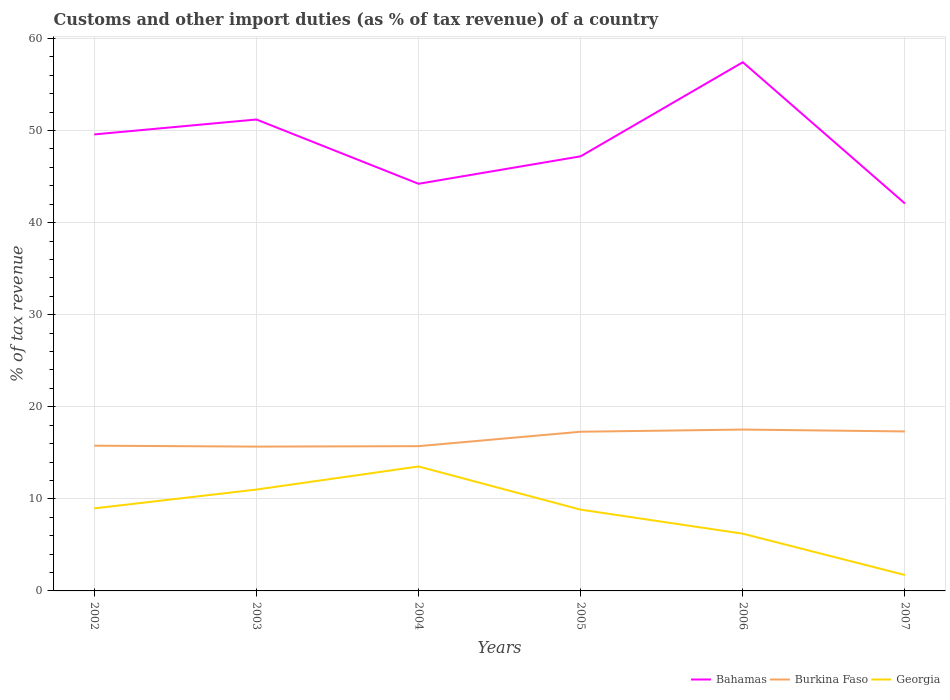How many different coloured lines are there?
Make the answer very short. 3. Is the number of lines equal to the number of legend labels?
Your answer should be very brief. Yes. Across all years, what is the maximum percentage of tax revenue from customs in Georgia?
Your answer should be compact. 1.73. In which year was the percentage of tax revenue from customs in Burkina Faso maximum?
Your answer should be very brief. 2003. What is the total percentage of tax revenue from customs in Burkina Faso in the graph?
Ensure brevity in your answer.  -1.61. What is the difference between the highest and the second highest percentage of tax revenue from customs in Bahamas?
Your answer should be very brief. 15.35. How many years are there in the graph?
Provide a short and direct response. 6. Does the graph contain grids?
Offer a terse response. Yes. How are the legend labels stacked?
Provide a succinct answer. Horizontal. What is the title of the graph?
Ensure brevity in your answer.  Customs and other import duties (as % of tax revenue) of a country. What is the label or title of the Y-axis?
Provide a succinct answer. % of tax revenue. What is the % of tax revenue of Bahamas in 2002?
Ensure brevity in your answer.  49.57. What is the % of tax revenue of Burkina Faso in 2002?
Ensure brevity in your answer.  15.77. What is the % of tax revenue of Georgia in 2002?
Make the answer very short. 8.96. What is the % of tax revenue of Bahamas in 2003?
Your answer should be very brief. 51.2. What is the % of tax revenue of Burkina Faso in 2003?
Keep it short and to the point. 15.67. What is the % of tax revenue of Georgia in 2003?
Provide a short and direct response. 11.01. What is the % of tax revenue in Bahamas in 2004?
Offer a very short reply. 44.21. What is the % of tax revenue in Burkina Faso in 2004?
Offer a terse response. 15.72. What is the % of tax revenue in Georgia in 2004?
Provide a short and direct response. 13.51. What is the % of tax revenue in Bahamas in 2005?
Offer a terse response. 47.2. What is the % of tax revenue of Burkina Faso in 2005?
Keep it short and to the point. 17.29. What is the % of tax revenue in Georgia in 2005?
Your answer should be very brief. 8.83. What is the % of tax revenue of Bahamas in 2006?
Give a very brief answer. 57.42. What is the % of tax revenue of Burkina Faso in 2006?
Your response must be concise. 17.52. What is the % of tax revenue of Georgia in 2006?
Offer a very short reply. 6.22. What is the % of tax revenue of Bahamas in 2007?
Give a very brief answer. 42.07. What is the % of tax revenue of Burkina Faso in 2007?
Offer a terse response. 17.32. What is the % of tax revenue in Georgia in 2007?
Provide a short and direct response. 1.73. Across all years, what is the maximum % of tax revenue of Bahamas?
Ensure brevity in your answer.  57.42. Across all years, what is the maximum % of tax revenue in Burkina Faso?
Provide a short and direct response. 17.52. Across all years, what is the maximum % of tax revenue of Georgia?
Keep it short and to the point. 13.51. Across all years, what is the minimum % of tax revenue of Bahamas?
Your answer should be compact. 42.07. Across all years, what is the minimum % of tax revenue of Burkina Faso?
Your response must be concise. 15.67. Across all years, what is the minimum % of tax revenue of Georgia?
Give a very brief answer. 1.73. What is the total % of tax revenue in Bahamas in the graph?
Offer a terse response. 291.67. What is the total % of tax revenue of Burkina Faso in the graph?
Provide a short and direct response. 99.3. What is the total % of tax revenue of Georgia in the graph?
Provide a succinct answer. 50.25. What is the difference between the % of tax revenue of Bahamas in 2002 and that in 2003?
Your response must be concise. -1.62. What is the difference between the % of tax revenue of Burkina Faso in 2002 and that in 2003?
Make the answer very short. 0.1. What is the difference between the % of tax revenue of Georgia in 2002 and that in 2003?
Make the answer very short. -2.04. What is the difference between the % of tax revenue in Bahamas in 2002 and that in 2004?
Ensure brevity in your answer.  5.36. What is the difference between the % of tax revenue of Burkina Faso in 2002 and that in 2004?
Provide a succinct answer. 0.05. What is the difference between the % of tax revenue of Georgia in 2002 and that in 2004?
Make the answer very short. -4.55. What is the difference between the % of tax revenue in Bahamas in 2002 and that in 2005?
Your answer should be compact. 2.38. What is the difference between the % of tax revenue of Burkina Faso in 2002 and that in 2005?
Give a very brief answer. -1.51. What is the difference between the % of tax revenue in Georgia in 2002 and that in 2005?
Provide a short and direct response. 0.14. What is the difference between the % of tax revenue in Bahamas in 2002 and that in 2006?
Offer a very short reply. -7.84. What is the difference between the % of tax revenue in Burkina Faso in 2002 and that in 2006?
Keep it short and to the point. -1.75. What is the difference between the % of tax revenue of Georgia in 2002 and that in 2006?
Your answer should be compact. 2.75. What is the difference between the % of tax revenue in Bahamas in 2002 and that in 2007?
Your answer should be very brief. 7.5. What is the difference between the % of tax revenue in Burkina Faso in 2002 and that in 2007?
Make the answer very short. -1.55. What is the difference between the % of tax revenue in Georgia in 2002 and that in 2007?
Make the answer very short. 7.24. What is the difference between the % of tax revenue of Bahamas in 2003 and that in 2004?
Offer a very short reply. 6.98. What is the difference between the % of tax revenue of Burkina Faso in 2003 and that in 2004?
Provide a short and direct response. -0.05. What is the difference between the % of tax revenue of Georgia in 2003 and that in 2004?
Provide a short and direct response. -2.51. What is the difference between the % of tax revenue in Bahamas in 2003 and that in 2005?
Your answer should be very brief. 4. What is the difference between the % of tax revenue in Burkina Faso in 2003 and that in 2005?
Your answer should be compact. -1.61. What is the difference between the % of tax revenue in Georgia in 2003 and that in 2005?
Offer a very short reply. 2.18. What is the difference between the % of tax revenue of Bahamas in 2003 and that in 2006?
Provide a succinct answer. -6.22. What is the difference between the % of tax revenue of Burkina Faso in 2003 and that in 2006?
Your response must be concise. -1.85. What is the difference between the % of tax revenue of Georgia in 2003 and that in 2006?
Provide a short and direct response. 4.79. What is the difference between the % of tax revenue in Bahamas in 2003 and that in 2007?
Offer a very short reply. 9.13. What is the difference between the % of tax revenue in Burkina Faso in 2003 and that in 2007?
Your response must be concise. -1.65. What is the difference between the % of tax revenue of Georgia in 2003 and that in 2007?
Your answer should be very brief. 9.28. What is the difference between the % of tax revenue of Bahamas in 2004 and that in 2005?
Give a very brief answer. -2.98. What is the difference between the % of tax revenue in Burkina Faso in 2004 and that in 2005?
Your answer should be compact. -1.57. What is the difference between the % of tax revenue in Georgia in 2004 and that in 2005?
Give a very brief answer. 4.69. What is the difference between the % of tax revenue of Bahamas in 2004 and that in 2006?
Provide a succinct answer. -13.2. What is the difference between the % of tax revenue in Burkina Faso in 2004 and that in 2006?
Your answer should be compact. -1.8. What is the difference between the % of tax revenue of Georgia in 2004 and that in 2006?
Your answer should be compact. 7.3. What is the difference between the % of tax revenue in Bahamas in 2004 and that in 2007?
Offer a very short reply. 2.14. What is the difference between the % of tax revenue of Burkina Faso in 2004 and that in 2007?
Your answer should be compact. -1.6. What is the difference between the % of tax revenue in Georgia in 2004 and that in 2007?
Ensure brevity in your answer.  11.79. What is the difference between the % of tax revenue of Bahamas in 2005 and that in 2006?
Keep it short and to the point. -10.22. What is the difference between the % of tax revenue of Burkina Faso in 2005 and that in 2006?
Give a very brief answer. -0.24. What is the difference between the % of tax revenue of Georgia in 2005 and that in 2006?
Offer a terse response. 2.61. What is the difference between the % of tax revenue in Bahamas in 2005 and that in 2007?
Provide a short and direct response. 5.13. What is the difference between the % of tax revenue of Burkina Faso in 2005 and that in 2007?
Your answer should be very brief. -0.03. What is the difference between the % of tax revenue in Georgia in 2005 and that in 2007?
Give a very brief answer. 7.1. What is the difference between the % of tax revenue in Bahamas in 2006 and that in 2007?
Your answer should be very brief. 15.35. What is the difference between the % of tax revenue in Burkina Faso in 2006 and that in 2007?
Offer a very short reply. 0.2. What is the difference between the % of tax revenue in Georgia in 2006 and that in 2007?
Your answer should be very brief. 4.49. What is the difference between the % of tax revenue of Bahamas in 2002 and the % of tax revenue of Burkina Faso in 2003?
Offer a very short reply. 33.9. What is the difference between the % of tax revenue of Bahamas in 2002 and the % of tax revenue of Georgia in 2003?
Your answer should be compact. 38.57. What is the difference between the % of tax revenue of Burkina Faso in 2002 and the % of tax revenue of Georgia in 2003?
Give a very brief answer. 4.76. What is the difference between the % of tax revenue of Bahamas in 2002 and the % of tax revenue of Burkina Faso in 2004?
Your answer should be compact. 33.85. What is the difference between the % of tax revenue in Bahamas in 2002 and the % of tax revenue in Georgia in 2004?
Offer a very short reply. 36.06. What is the difference between the % of tax revenue in Burkina Faso in 2002 and the % of tax revenue in Georgia in 2004?
Your answer should be compact. 2.26. What is the difference between the % of tax revenue in Bahamas in 2002 and the % of tax revenue in Burkina Faso in 2005?
Your answer should be compact. 32.29. What is the difference between the % of tax revenue of Bahamas in 2002 and the % of tax revenue of Georgia in 2005?
Make the answer very short. 40.75. What is the difference between the % of tax revenue in Burkina Faso in 2002 and the % of tax revenue in Georgia in 2005?
Provide a succinct answer. 6.95. What is the difference between the % of tax revenue of Bahamas in 2002 and the % of tax revenue of Burkina Faso in 2006?
Give a very brief answer. 32.05. What is the difference between the % of tax revenue of Bahamas in 2002 and the % of tax revenue of Georgia in 2006?
Provide a short and direct response. 43.36. What is the difference between the % of tax revenue of Burkina Faso in 2002 and the % of tax revenue of Georgia in 2006?
Offer a terse response. 9.56. What is the difference between the % of tax revenue of Bahamas in 2002 and the % of tax revenue of Burkina Faso in 2007?
Provide a short and direct response. 32.25. What is the difference between the % of tax revenue of Bahamas in 2002 and the % of tax revenue of Georgia in 2007?
Offer a very short reply. 47.85. What is the difference between the % of tax revenue of Burkina Faso in 2002 and the % of tax revenue of Georgia in 2007?
Keep it short and to the point. 14.04. What is the difference between the % of tax revenue in Bahamas in 2003 and the % of tax revenue in Burkina Faso in 2004?
Offer a very short reply. 35.47. What is the difference between the % of tax revenue in Bahamas in 2003 and the % of tax revenue in Georgia in 2004?
Provide a succinct answer. 37.68. What is the difference between the % of tax revenue in Burkina Faso in 2003 and the % of tax revenue in Georgia in 2004?
Keep it short and to the point. 2.16. What is the difference between the % of tax revenue in Bahamas in 2003 and the % of tax revenue in Burkina Faso in 2005?
Make the answer very short. 33.91. What is the difference between the % of tax revenue in Bahamas in 2003 and the % of tax revenue in Georgia in 2005?
Your response must be concise. 42.37. What is the difference between the % of tax revenue in Burkina Faso in 2003 and the % of tax revenue in Georgia in 2005?
Your answer should be very brief. 6.85. What is the difference between the % of tax revenue of Bahamas in 2003 and the % of tax revenue of Burkina Faso in 2006?
Keep it short and to the point. 33.67. What is the difference between the % of tax revenue of Bahamas in 2003 and the % of tax revenue of Georgia in 2006?
Keep it short and to the point. 44.98. What is the difference between the % of tax revenue in Burkina Faso in 2003 and the % of tax revenue in Georgia in 2006?
Give a very brief answer. 9.46. What is the difference between the % of tax revenue of Bahamas in 2003 and the % of tax revenue of Burkina Faso in 2007?
Make the answer very short. 33.88. What is the difference between the % of tax revenue in Bahamas in 2003 and the % of tax revenue in Georgia in 2007?
Give a very brief answer. 49.47. What is the difference between the % of tax revenue in Burkina Faso in 2003 and the % of tax revenue in Georgia in 2007?
Make the answer very short. 13.95. What is the difference between the % of tax revenue of Bahamas in 2004 and the % of tax revenue of Burkina Faso in 2005?
Keep it short and to the point. 26.93. What is the difference between the % of tax revenue in Bahamas in 2004 and the % of tax revenue in Georgia in 2005?
Ensure brevity in your answer.  35.39. What is the difference between the % of tax revenue of Burkina Faso in 2004 and the % of tax revenue of Georgia in 2005?
Provide a succinct answer. 6.9. What is the difference between the % of tax revenue in Bahamas in 2004 and the % of tax revenue in Burkina Faso in 2006?
Ensure brevity in your answer.  26.69. What is the difference between the % of tax revenue in Bahamas in 2004 and the % of tax revenue in Georgia in 2006?
Keep it short and to the point. 38. What is the difference between the % of tax revenue of Burkina Faso in 2004 and the % of tax revenue of Georgia in 2006?
Offer a terse response. 9.51. What is the difference between the % of tax revenue in Bahamas in 2004 and the % of tax revenue in Burkina Faso in 2007?
Ensure brevity in your answer.  26.89. What is the difference between the % of tax revenue in Bahamas in 2004 and the % of tax revenue in Georgia in 2007?
Your response must be concise. 42.49. What is the difference between the % of tax revenue of Burkina Faso in 2004 and the % of tax revenue of Georgia in 2007?
Provide a short and direct response. 13.99. What is the difference between the % of tax revenue of Bahamas in 2005 and the % of tax revenue of Burkina Faso in 2006?
Provide a succinct answer. 29.67. What is the difference between the % of tax revenue of Bahamas in 2005 and the % of tax revenue of Georgia in 2006?
Offer a very short reply. 40.98. What is the difference between the % of tax revenue of Burkina Faso in 2005 and the % of tax revenue of Georgia in 2006?
Make the answer very short. 11.07. What is the difference between the % of tax revenue of Bahamas in 2005 and the % of tax revenue of Burkina Faso in 2007?
Your response must be concise. 29.88. What is the difference between the % of tax revenue of Bahamas in 2005 and the % of tax revenue of Georgia in 2007?
Keep it short and to the point. 45.47. What is the difference between the % of tax revenue of Burkina Faso in 2005 and the % of tax revenue of Georgia in 2007?
Give a very brief answer. 15.56. What is the difference between the % of tax revenue in Bahamas in 2006 and the % of tax revenue in Burkina Faso in 2007?
Provide a short and direct response. 40.1. What is the difference between the % of tax revenue in Bahamas in 2006 and the % of tax revenue in Georgia in 2007?
Your response must be concise. 55.69. What is the difference between the % of tax revenue in Burkina Faso in 2006 and the % of tax revenue in Georgia in 2007?
Your response must be concise. 15.8. What is the average % of tax revenue of Bahamas per year?
Your answer should be compact. 48.61. What is the average % of tax revenue of Burkina Faso per year?
Your response must be concise. 16.55. What is the average % of tax revenue of Georgia per year?
Ensure brevity in your answer.  8.38. In the year 2002, what is the difference between the % of tax revenue in Bahamas and % of tax revenue in Burkina Faso?
Provide a succinct answer. 33.8. In the year 2002, what is the difference between the % of tax revenue of Bahamas and % of tax revenue of Georgia?
Provide a short and direct response. 40.61. In the year 2002, what is the difference between the % of tax revenue in Burkina Faso and % of tax revenue in Georgia?
Your answer should be compact. 6.81. In the year 2003, what is the difference between the % of tax revenue of Bahamas and % of tax revenue of Burkina Faso?
Ensure brevity in your answer.  35.52. In the year 2003, what is the difference between the % of tax revenue of Bahamas and % of tax revenue of Georgia?
Offer a very short reply. 40.19. In the year 2003, what is the difference between the % of tax revenue in Burkina Faso and % of tax revenue in Georgia?
Your answer should be very brief. 4.66. In the year 2004, what is the difference between the % of tax revenue in Bahamas and % of tax revenue in Burkina Faso?
Give a very brief answer. 28.49. In the year 2004, what is the difference between the % of tax revenue in Bahamas and % of tax revenue in Georgia?
Give a very brief answer. 30.7. In the year 2004, what is the difference between the % of tax revenue of Burkina Faso and % of tax revenue of Georgia?
Your answer should be very brief. 2.21. In the year 2005, what is the difference between the % of tax revenue in Bahamas and % of tax revenue in Burkina Faso?
Provide a succinct answer. 29.91. In the year 2005, what is the difference between the % of tax revenue of Bahamas and % of tax revenue of Georgia?
Offer a very short reply. 38.37. In the year 2005, what is the difference between the % of tax revenue of Burkina Faso and % of tax revenue of Georgia?
Offer a terse response. 8.46. In the year 2006, what is the difference between the % of tax revenue in Bahamas and % of tax revenue in Burkina Faso?
Provide a short and direct response. 39.89. In the year 2006, what is the difference between the % of tax revenue of Bahamas and % of tax revenue of Georgia?
Your response must be concise. 51.2. In the year 2006, what is the difference between the % of tax revenue of Burkina Faso and % of tax revenue of Georgia?
Make the answer very short. 11.31. In the year 2007, what is the difference between the % of tax revenue of Bahamas and % of tax revenue of Burkina Faso?
Your answer should be compact. 24.75. In the year 2007, what is the difference between the % of tax revenue in Bahamas and % of tax revenue in Georgia?
Keep it short and to the point. 40.34. In the year 2007, what is the difference between the % of tax revenue of Burkina Faso and % of tax revenue of Georgia?
Make the answer very short. 15.59. What is the ratio of the % of tax revenue in Bahamas in 2002 to that in 2003?
Your response must be concise. 0.97. What is the ratio of the % of tax revenue of Georgia in 2002 to that in 2003?
Make the answer very short. 0.81. What is the ratio of the % of tax revenue of Bahamas in 2002 to that in 2004?
Offer a very short reply. 1.12. What is the ratio of the % of tax revenue of Georgia in 2002 to that in 2004?
Offer a terse response. 0.66. What is the ratio of the % of tax revenue of Bahamas in 2002 to that in 2005?
Provide a succinct answer. 1.05. What is the ratio of the % of tax revenue of Burkina Faso in 2002 to that in 2005?
Your answer should be very brief. 0.91. What is the ratio of the % of tax revenue in Georgia in 2002 to that in 2005?
Make the answer very short. 1.02. What is the ratio of the % of tax revenue in Bahamas in 2002 to that in 2006?
Make the answer very short. 0.86. What is the ratio of the % of tax revenue of Burkina Faso in 2002 to that in 2006?
Your answer should be compact. 0.9. What is the ratio of the % of tax revenue in Georgia in 2002 to that in 2006?
Your answer should be compact. 1.44. What is the ratio of the % of tax revenue of Bahamas in 2002 to that in 2007?
Offer a terse response. 1.18. What is the ratio of the % of tax revenue in Burkina Faso in 2002 to that in 2007?
Offer a very short reply. 0.91. What is the ratio of the % of tax revenue in Georgia in 2002 to that in 2007?
Your answer should be very brief. 5.19. What is the ratio of the % of tax revenue in Bahamas in 2003 to that in 2004?
Give a very brief answer. 1.16. What is the ratio of the % of tax revenue in Burkina Faso in 2003 to that in 2004?
Provide a short and direct response. 1. What is the ratio of the % of tax revenue in Georgia in 2003 to that in 2004?
Your response must be concise. 0.81. What is the ratio of the % of tax revenue in Bahamas in 2003 to that in 2005?
Offer a terse response. 1.08. What is the ratio of the % of tax revenue in Burkina Faso in 2003 to that in 2005?
Offer a terse response. 0.91. What is the ratio of the % of tax revenue of Georgia in 2003 to that in 2005?
Offer a terse response. 1.25. What is the ratio of the % of tax revenue in Bahamas in 2003 to that in 2006?
Give a very brief answer. 0.89. What is the ratio of the % of tax revenue of Burkina Faso in 2003 to that in 2006?
Provide a succinct answer. 0.89. What is the ratio of the % of tax revenue of Georgia in 2003 to that in 2006?
Your answer should be compact. 1.77. What is the ratio of the % of tax revenue of Bahamas in 2003 to that in 2007?
Your answer should be compact. 1.22. What is the ratio of the % of tax revenue in Burkina Faso in 2003 to that in 2007?
Provide a short and direct response. 0.9. What is the ratio of the % of tax revenue in Georgia in 2003 to that in 2007?
Keep it short and to the point. 6.37. What is the ratio of the % of tax revenue in Bahamas in 2004 to that in 2005?
Keep it short and to the point. 0.94. What is the ratio of the % of tax revenue of Burkina Faso in 2004 to that in 2005?
Keep it short and to the point. 0.91. What is the ratio of the % of tax revenue of Georgia in 2004 to that in 2005?
Provide a succinct answer. 1.53. What is the ratio of the % of tax revenue of Bahamas in 2004 to that in 2006?
Ensure brevity in your answer.  0.77. What is the ratio of the % of tax revenue of Burkina Faso in 2004 to that in 2006?
Ensure brevity in your answer.  0.9. What is the ratio of the % of tax revenue in Georgia in 2004 to that in 2006?
Provide a succinct answer. 2.17. What is the ratio of the % of tax revenue of Bahamas in 2004 to that in 2007?
Provide a short and direct response. 1.05. What is the ratio of the % of tax revenue in Burkina Faso in 2004 to that in 2007?
Provide a short and direct response. 0.91. What is the ratio of the % of tax revenue of Georgia in 2004 to that in 2007?
Keep it short and to the point. 7.82. What is the ratio of the % of tax revenue of Bahamas in 2005 to that in 2006?
Offer a very short reply. 0.82. What is the ratio of the % of tax revenue of Burkina Faso in 2005 to that in 2006?
Your response must be concise. 0.99. What is the ratio of the % of tax revenue in Georgia in 2005 to that in 2006?
Your answer should be very brief. 1.42. What is the ratio of the % of tax revenue of Bahamas in 2005 to that in 2007?
Make the answer very short. 1.12. What is the ratio of the % of tax revenue in Burkina Faso in 2005 to that in 2007?
Provide a short and direct response. 1. What is the ratio of the % of tax revenue of Georgia in 2005 to that in 2007?
Ensure brevity in your answer.  5.11. What is the ratio of the % of tax revenue in Bahamas in 2006 to that in 2007?
Ensure brevity in your answer.  1.36. What is the ratio of the % of tax revenue in Burkina Faso in 2006 to that in 2007?
Ensure brevity in your answer.  1.01. What is the ratio of the % of tax revenue of Georgia in 2006 to that in 2007?
Offer a terse response. 3.6. What is the difference between the highest and the second highest % of tax revenue in Bahamas?
Keep it short and to the point. 6.22. What is the difference between the highest and the second highest % of tax revenue of Burkina Faso?
Your response must be concise. 0.2. What is the difference between the highest and the second highest % of tax revenue of Georgia?
Your answer should be compact. 2.51. What is the difference between the highest and the lowest % of tax revenue of Bahamas?
Make the answer very short. 15.35. What is the difference between the highest and the lowest % of tax revenue in Burkina Faso?
Ensure brevity in your answer.  1.85. What is the difference between the highest and the lowest % of tax revenue of Georgia?
Offer a terse response. 11.79. 